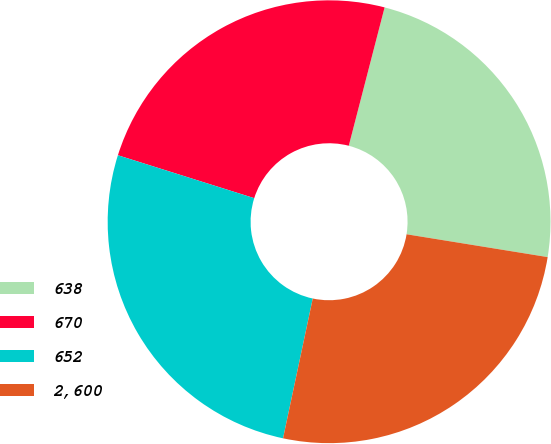Convert chart to OTSL. <chart><loc_0><loc_0><loc_500><loc_500><pie_chart><fcel>638<fcel>670<fcel>652<fcel>2,600<nl><fcel>23.52%<fcel>24.18%<fcel>26.52%<fcel>25.78%<nl></chart> 